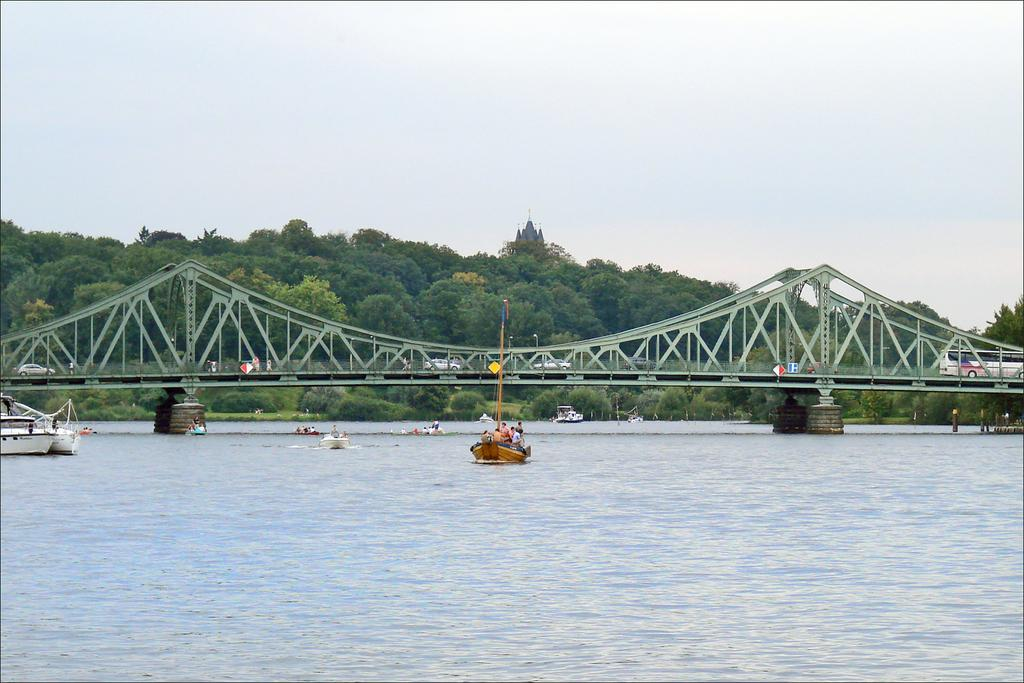What is on the water in the image? There are boats on the water in the image. What can be seen in the background of the image? There is a bridge and trees in the background of the image. What is on the bridge in the image? There are vehicles on the bridge. What is visible above the bridge in the image? The sky is visible in the background of the image. What type of paper is being used to make the boats float in the image? There is no paper present in the image, and the boats are floating on water, not paper. What rule is being enforced by the trees in the image? The trees in the image are not enforcing any rules; they are simply part of the background. 